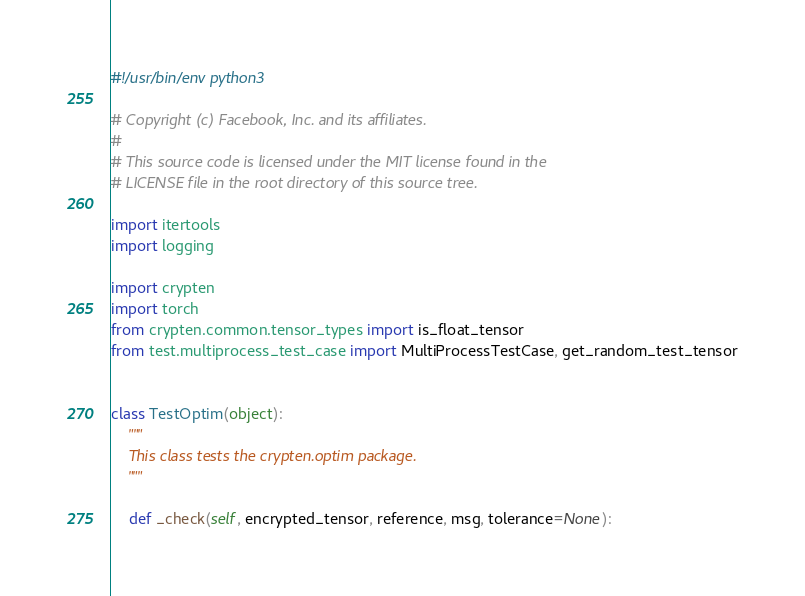Convert code to text. <code><loc_0><loc_0><loc_500><loc_500><_Python_>#!/usr/bin/env python3

# Copyright (c) Facebook, Inc. and its affiliates.
#
# This source code is licensed under the MIT license found in the
# LICENSE file in the root directory of this source tree.

import itertools
import logging

import crypten
import torch
from crypten.common.tensor_types import is_float_tensor
from test.multiprocess_test_case import MultiProcessTestCase, get_random_test_tensor


class TestOptim(object):
    """
    This class tests the crypten.optim package.
    """

    def _check(self, encrypted_tensor, reference, msg, tolerance=None):</code> 